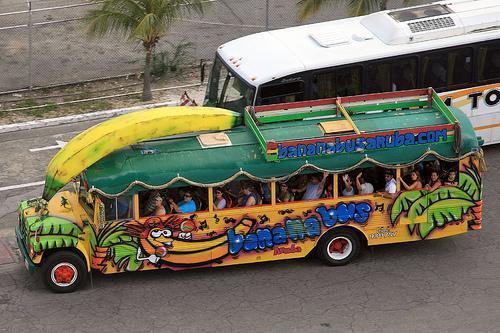How many buses are there in the photo?
Give a very brief answer. 2. 